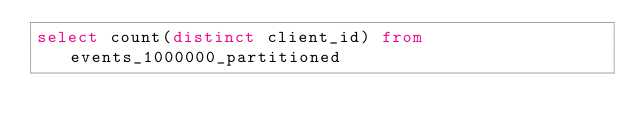Convert code to text. <code><loc_0><loc_0><loc_500><loc_500><_SQL_>select count(distinct client_id) from events_1000000_partitioned</code> 